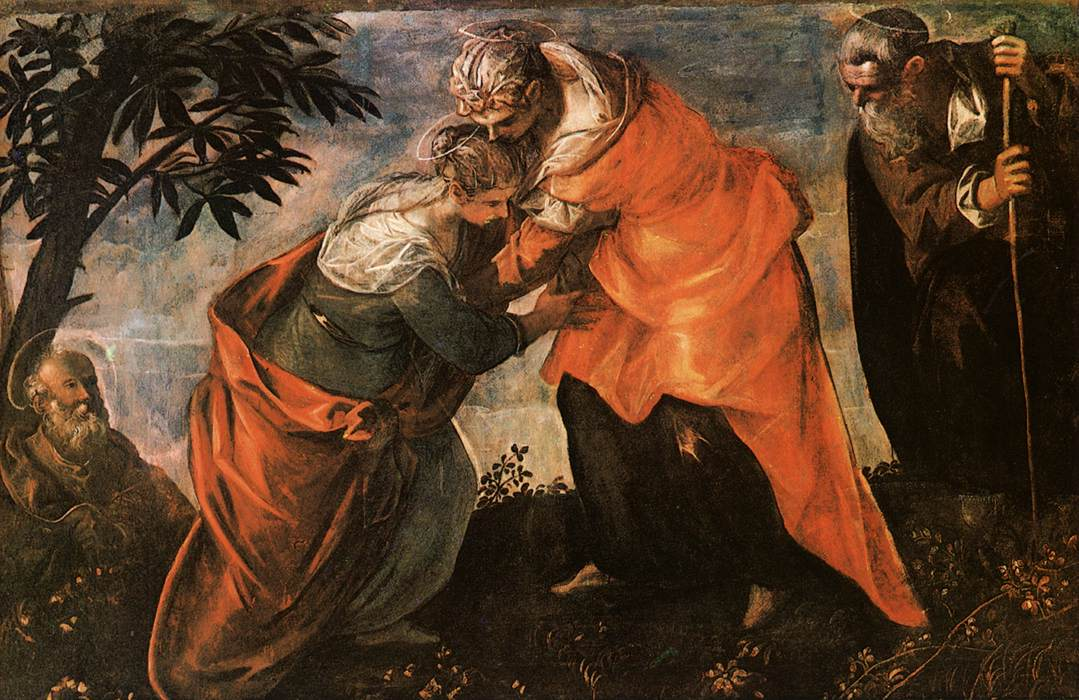Can you tell me more about the historical and artistic significance of this scene? Certainly! This painting illustrates the Visitation, where Mary, the mother of Jesus, visits her cousin Elizabeth, who is also miraculously pregnant with John the Baptist. This moment is key in Christian narratives, highlighting themes of joy and divine connection. Artistically, the scene is depicted in the style of the Renaissance, a period that emphasized humanism, the study of classical antiquity, and a more lifelike approach to painting. The choice to depict this spiritual event with such realistic detail and emotional depth shows the artist's intent to make the biblical tale accessible and resonant to viewers of that time. What does the setting imply about the context of the encounter? The lush garden setting is symbolic and important. It surrounds the figures with signs of life and natural beauty, which may symbolize the purity and spiritual significance of Mary and Elizabeth's encounter. Additionally, Renaissance artists often used backgrounds to add layers of meaning to the story. In this case, the serene environment emphasizes peace and divine blessing, underlining the sacredness of both women's pregnancies and their roles in the biblical narrative. 